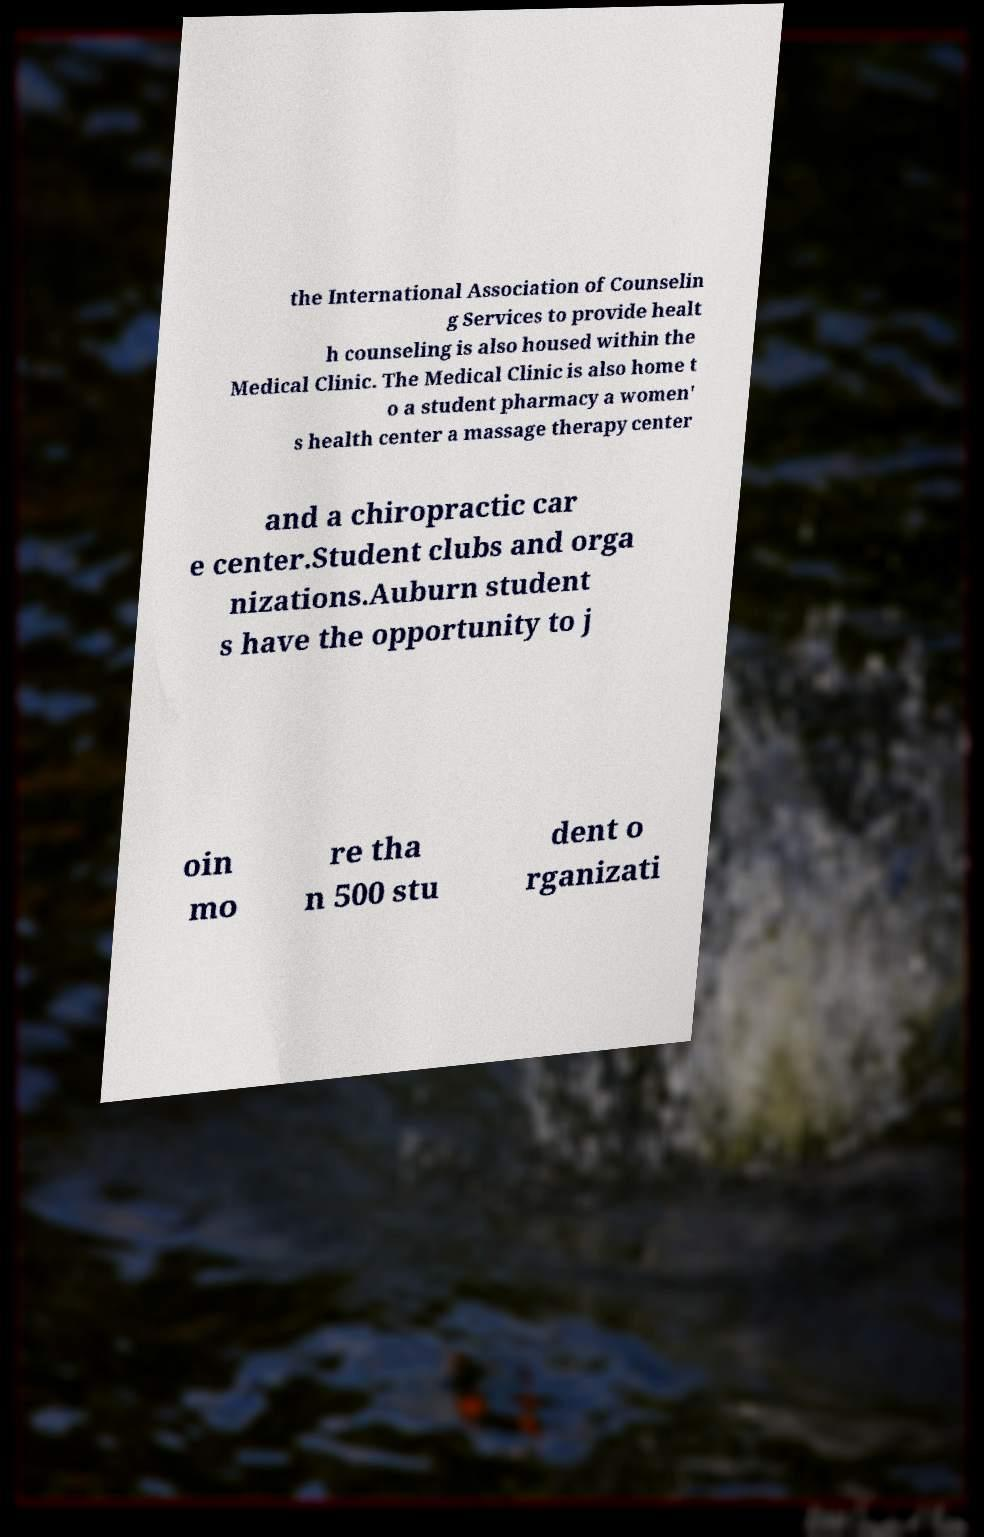Please read and relay the text visible in this image. What does it say? the International Association of Counselin g Services to provide healt h counseling is also housed within the Medical Clinic. The Medical Clinic is also home t o a student pharmacy a women' s health center a massage therapy center and a chiropractic car e center.Student clubs and orga nizations.Auburn student s have the opportunity to j oin mo re tha n 500 stu dent o rganizati 